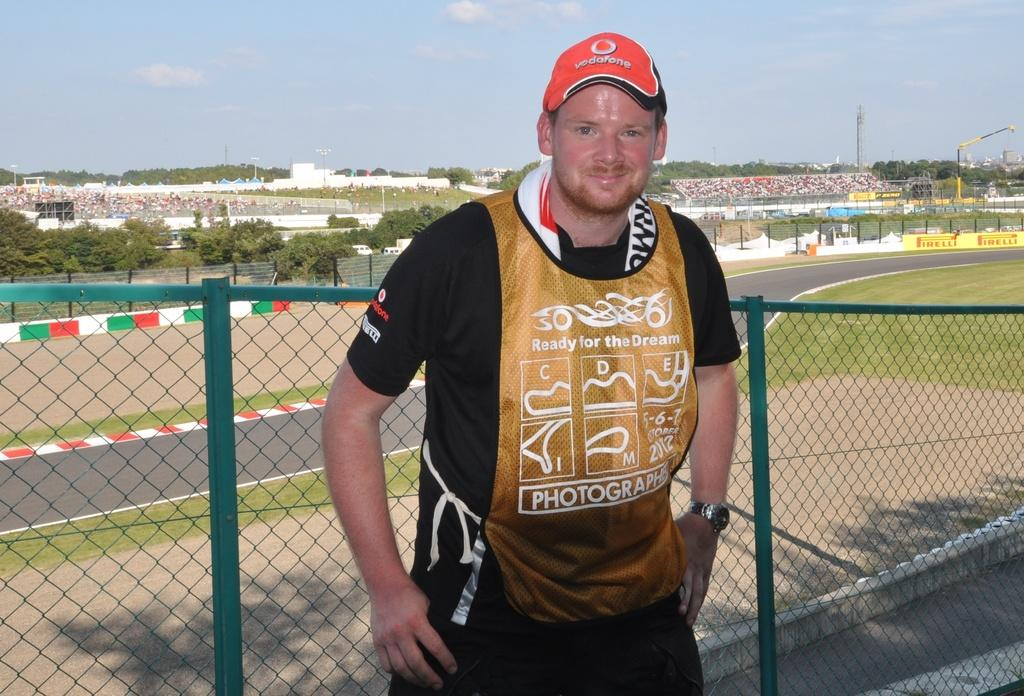<image>
Provide a brief description of the given image. A man wearing a golden shirt saying Ready for the Dream 